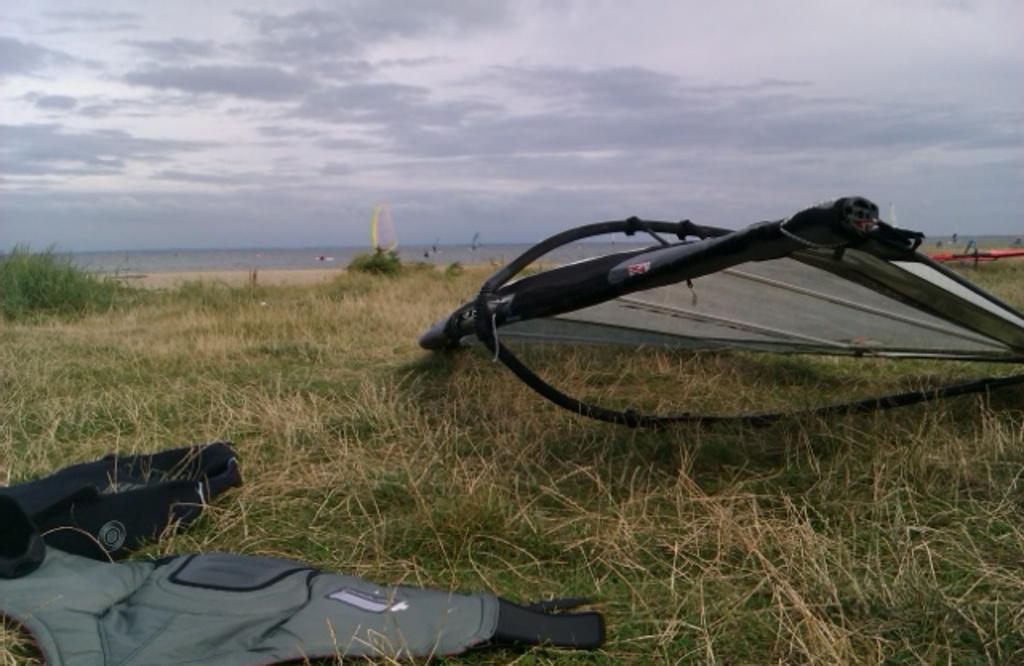Please provide a concise description of this image. In this image at the bottom there is grass, and on the grass there are some objects. In the background there are some plants, and their might be a river and some objects. At the top of the image there is sky. 